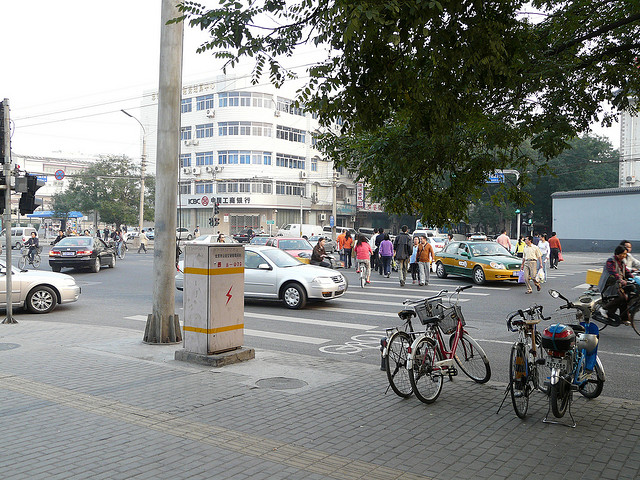Please identify all text content in this image. KBC 